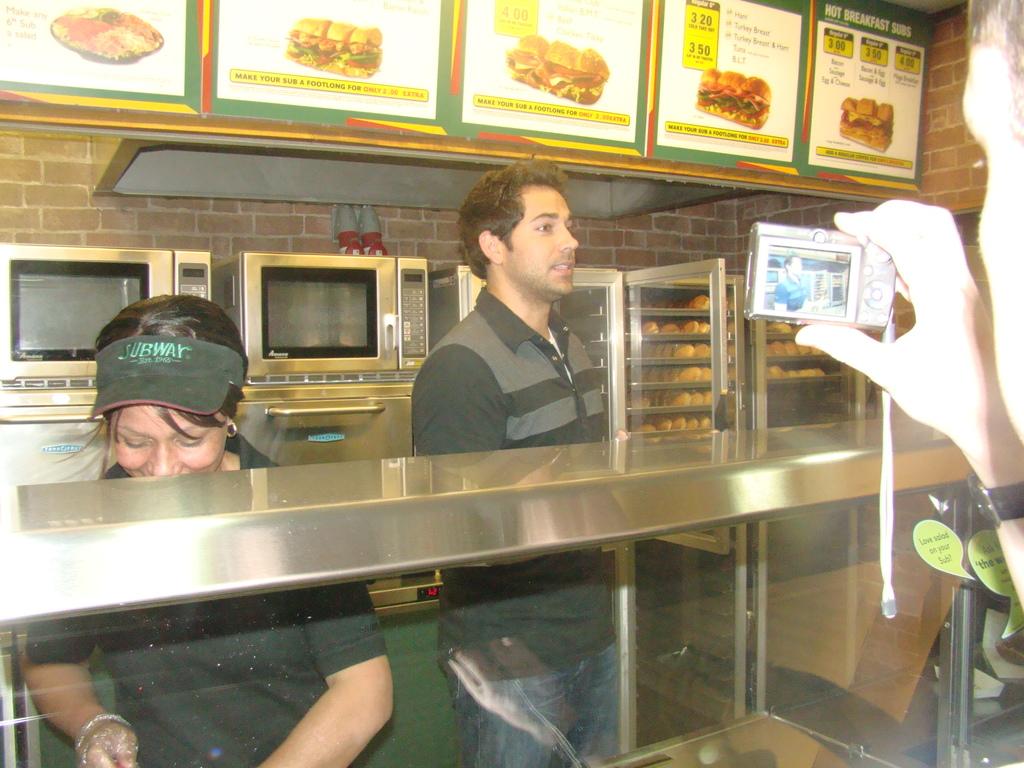What is the name of the restaurant?
Keep it short and to the point. Subway. 